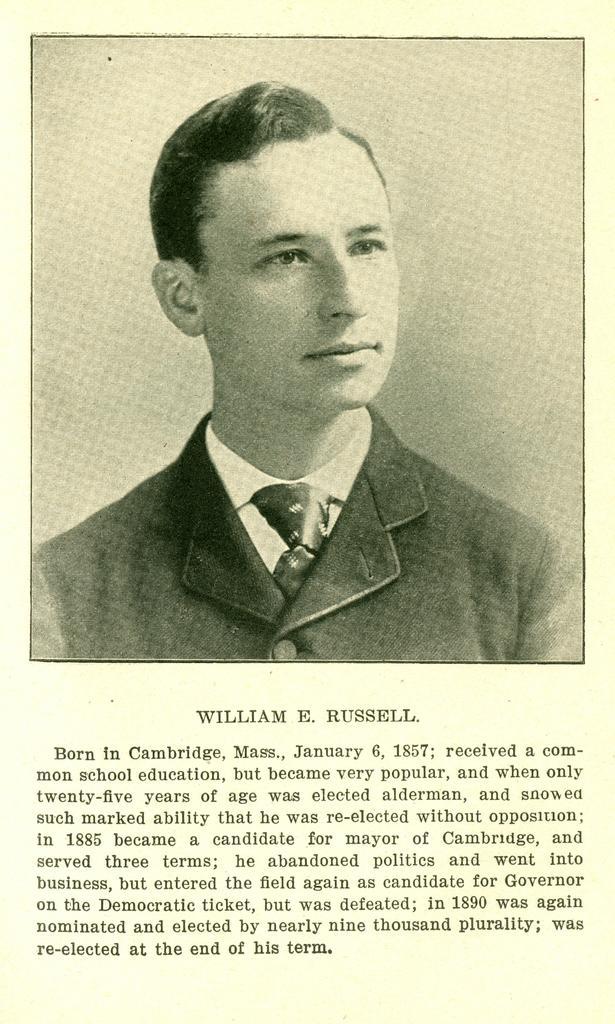Could you give a brief overview of what you see in this image? A picture of a person. Something written under this picture. 